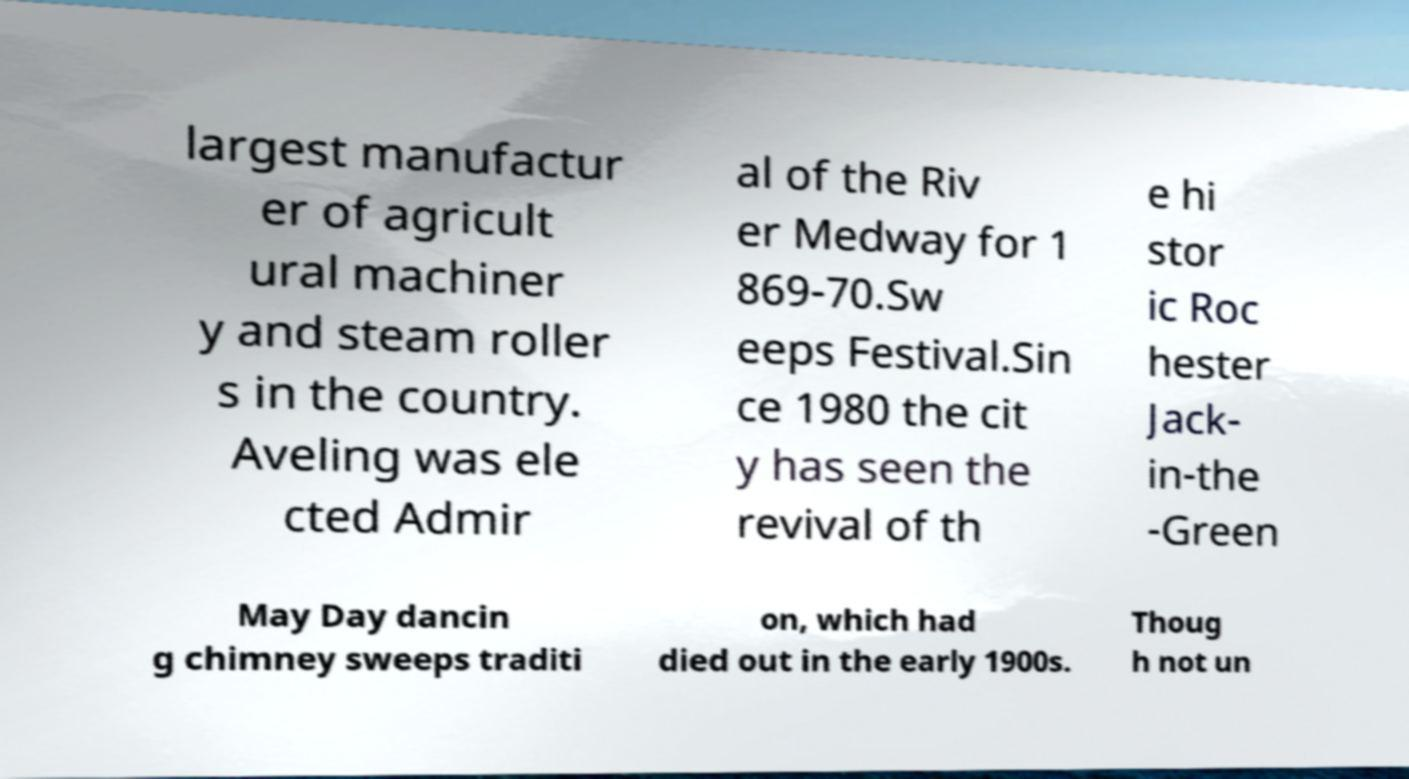I need the written content from this picture converted into text. Can you do that? largest manufactur er of agricult ural machiner y and steam roller s in the country. Aveling was ele cted Admir al of the Riv er Medway for 1 869-70.Sw eeps Festival.Sin ce 1980 the cit y has seen the revival of th e hi stor ic Roc hester Jack- in-the -Green May Day dancin g chimney sweeps traditi on, which had died out in the early 1900s. Thoug h not un 